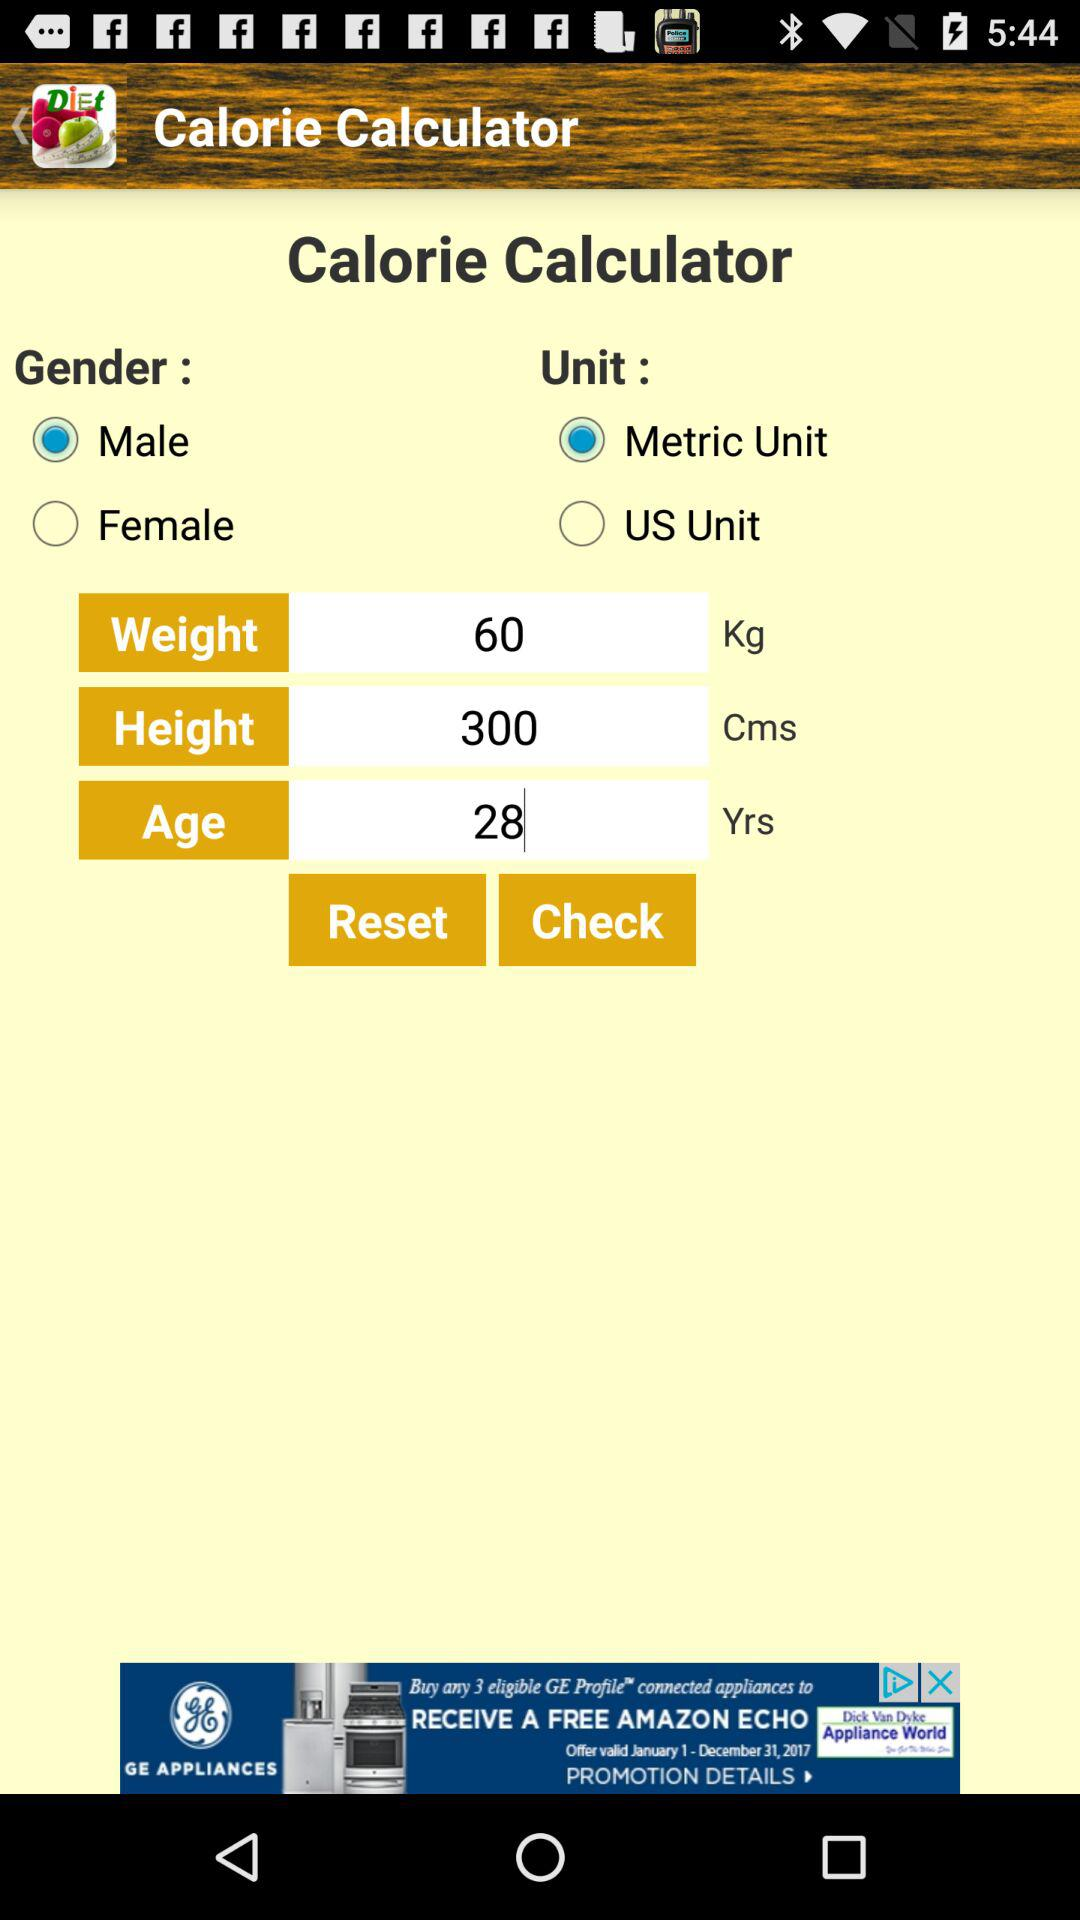What is the selected unit? The selected unit is "Metric Unit". 